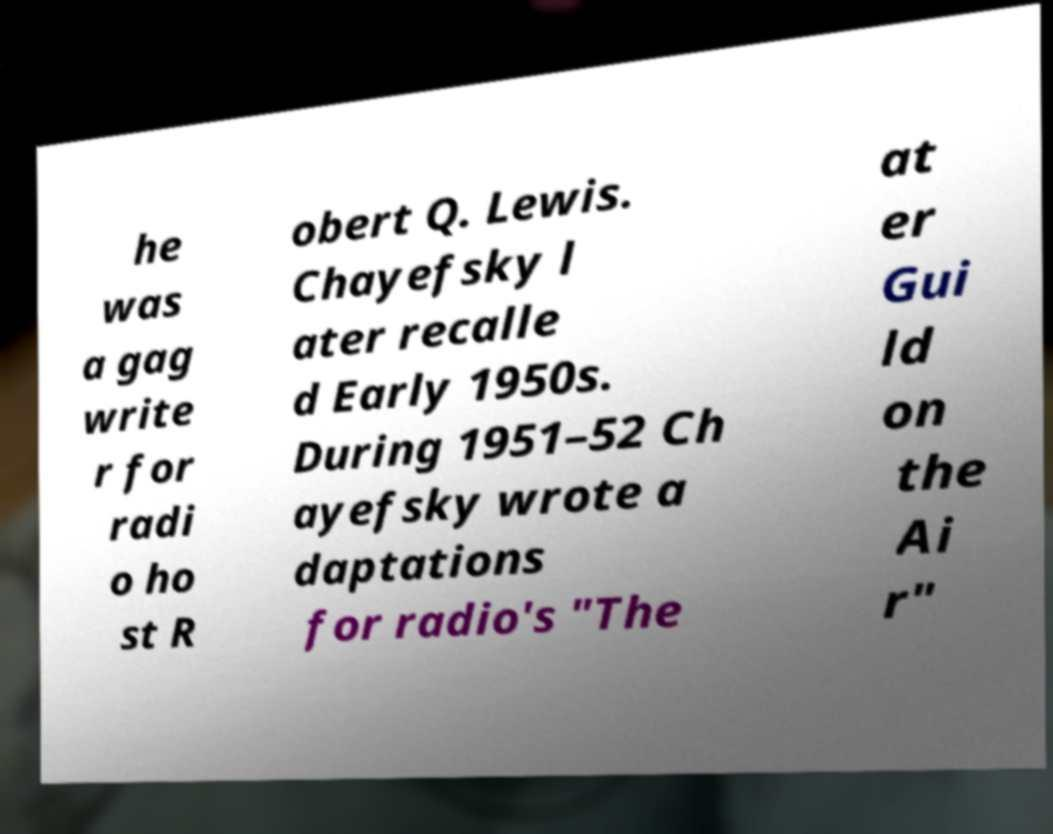Please read and relay the text visible in this image. What does it say? he was a gag write r for radi o ho st R obert Q. Lewis. Chayefsky l ater recalle d Early 1950s. During 1951–52 Ch ayefsky wrote a daptations for radio's "The at er Gui ld on the Ai r" 